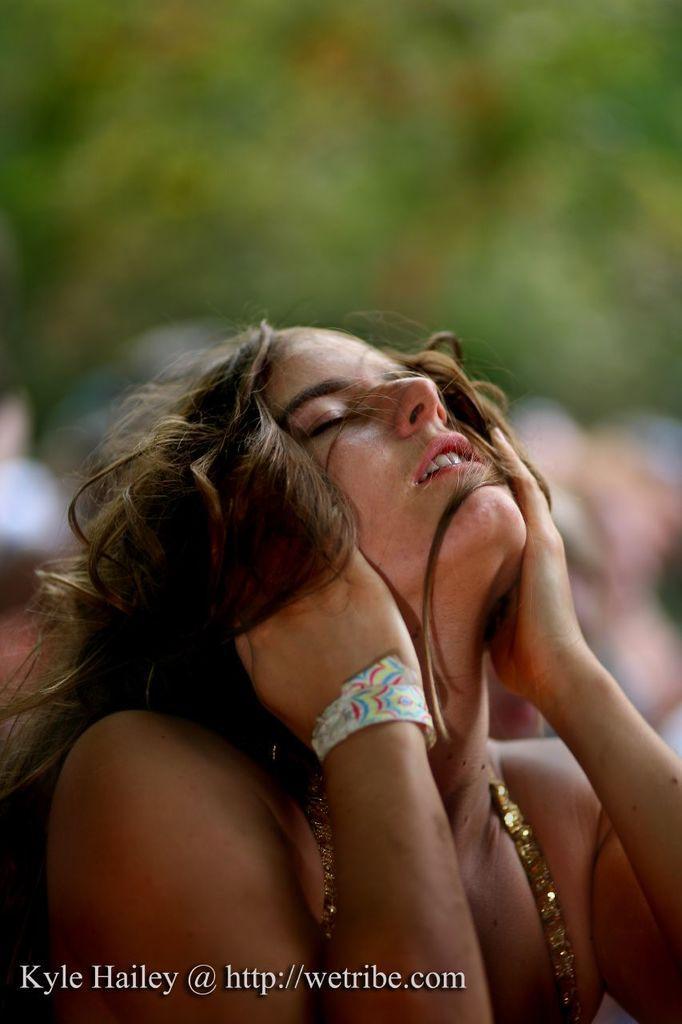Can you describe this image briefly? In the center of the image there is a woman. In the background there are people and trees. At the bottom there is a text. 